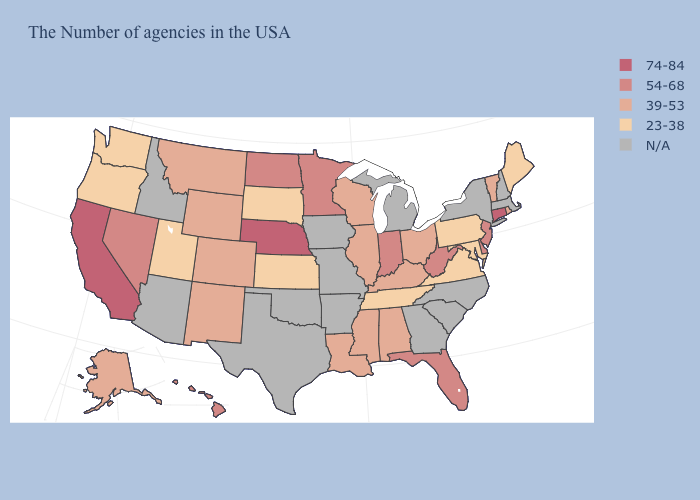What is the value of Connecticut?
Answer briefly. 74-84. Name the states that have a value in the range 39-53?
Keep it brief. Rhode Island, Vermont, Ohio, Kentucky, Alabama, Wisconsin, Illinois, Mississippi, Louisiana, Wyoming, Colorado, New Mexico, Montana, Alaska. Name the states that have a value in the range 54-68?
Be succinct. New Jersey, Delaware, West Virginia, Florida, Indiana, Minnesota, North Dakota, Nevada, Hawaii. Name the states that have a value in the range 23-38?
Keep it brief. Maine, Maryland, Pennsylvania, Virginia, Tennessee, Kansas, South Dakota, Utah, Washington, Oregon. Name the states that have a value in the range 74-84?
Be succinct. Connecticut, Nebraska, California. Name the states that have a value in the range 54-68?
Be succinct. New Jersey, Delaware, West Virginia, Florida, Indiana, Minnesota, North Dakota, Nevada, Hawaii. What is the value of South Carolina?
Keep it brief. N/A. What is the value of New Jersey?
Concise answer only. 54-68. What is the lowest value in states that border Indiana?
Answer briefly. 39-53. Among the states that border New Hampshire , does Maine have the lowest value?
Be succinct. Yes. Is the legend a continuous bar?
Quick response, please. No. Is the legend a continuous bar?
Give a very brief answer. No. What is the value of New York?
Short answer required. N/A. What is the value of Maryland?
Be succinct. 23-38. 